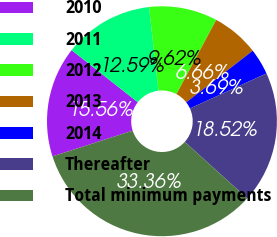<chart> <loc_0><loc_0><loc_500><loc_500><pie_chart><fcel>2010<fcel>2011<fcel>2012<fcel>2013<fcel>2014<fcel>Thereafter<fcel>Total minimum payments<nl><fcel>15.56%<fcel>12.59%<fcel>9.62%<fcel>6.66%<fcel>3.69%<fcel>18.52%<fcel>33.36%<nl></chart> 